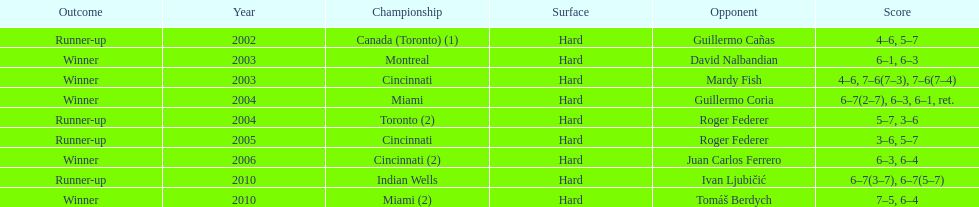How many consecutive years was there a hard surface at the championship? 9. 